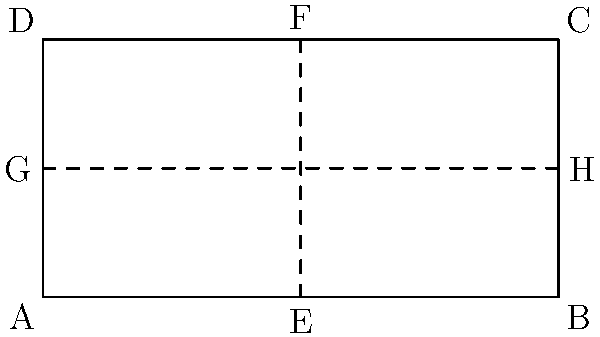As a military strategist and football enthusiast, imagine folding a miniature football field diagram as shown above. If you fold the field along the vertical line EF first, then along the horizontal line GH, which corner will end up on top of corner A? Let's approach this step-by-step:

1. The field is divided into four equal rectangles by the dashed lines.

2. First fold along line EF:
   - This fold brings the right half of the field over the left half.
   - Corner B will now be on top of corner A.
   - Corner C will be on top of corner D.

3. After the first fold, we have:
   - Bottom layer: Rectangle AEGD
   - Top layer: Rectangle BFHC (flipped)

4. Now fold along line GH:
   - This fold brings the top half of the already folded field over the bottom half.
   - The top layer (previously BFHC) will now be sandwiched in the middle.

5. After the second fold, from bottom to top, we have:
   - Bottom: Lower half of AEGD
   - Middle: BFHC (flipped)
   - Top: Upper half of AEGD (flipped)

6. Therefore, corner C, which was on top of D after the first fold, will end up on top of corner A after the second fold.

This folding technique is similar to some military map-folding methods, which allow for quick reference to specific areas while maintaining the overall structure of the map.
Answer: C 